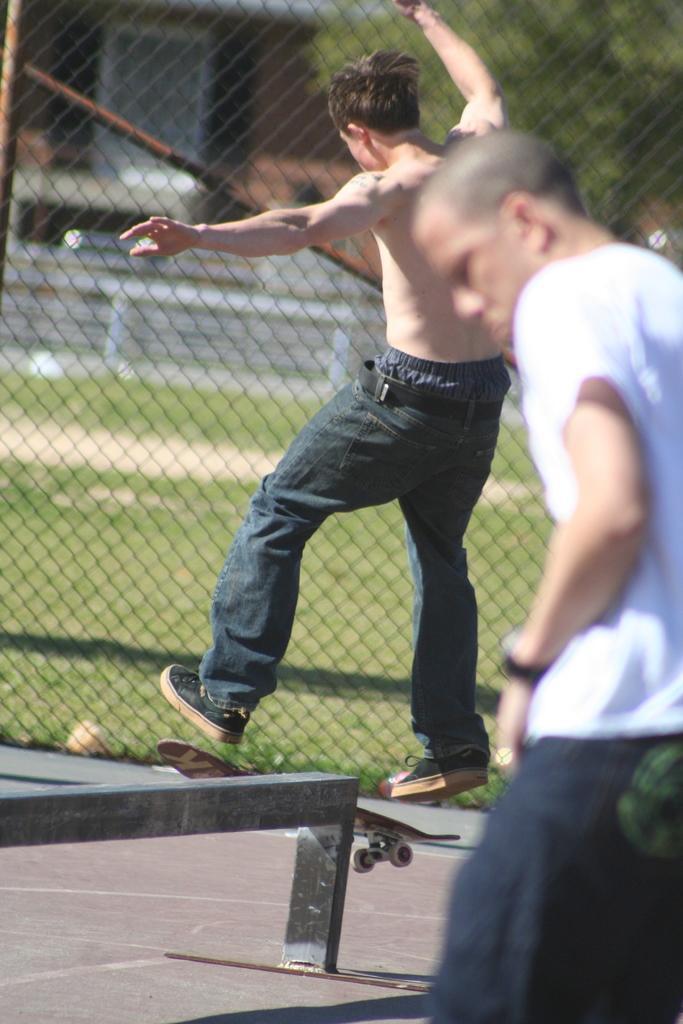How would you summarize this image in a sentence or two? There is a person on a skateboard. Near to that there is a small wall. On the right side there is a person. In the back there is a mesh wall. 